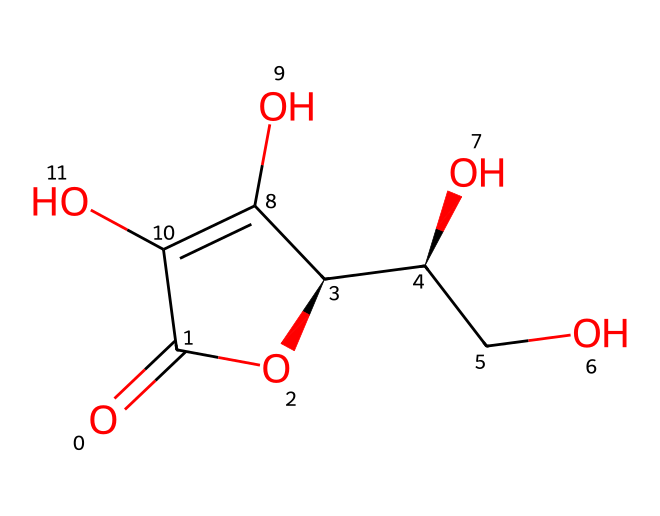What is the common name for this compound? The chemical structure corresponds to ascorbic acid, which is commonly known as Vitamin C. This name is widely recognized in the context of nutrition and biochemistry.
Answer: Vitamin C How many oxygen atoms are present in the molecule? By examining the structure, there are a total of 4 oxygen atoms present. The structure shows several –OH groups and a carbonyl group (C=O), contributing to the total count.
Answer: 4 What functional groups are present in ascorbic acid? The structure reveals multiple hydroxyl groups (–OH) and one carbonyl group (C=O), which are characteristic of alcohols and aldehydes, respectively. These functional groups dictate the molecule's reactivity and solubility properties.
Answer: hydroxyl and carbonyl What is the molecular formula of ascorbic acid? Analyzing the structure reveals the number of carbon (C), hydrogen (H), and oxygen (O) atoms. Upon counting, there are 6 carbons, 8 hydrogens, and 6 oxygens, leading to the molecular formula C6H8O6.
Answer: C6H8O6 Is this molecule polar or nonpolar? The presence of multiple hydroxyl groups lends significant polarity to the structure due to the electronegativity of oxygen atoms. Additionally, hydrogen bonding capabilities enhance its polar characteristics.
Answer: polar What is the primary role of ascorbic acid in human health? Ascorbic acid's primary function is as an antioxidant, helping to neutralize free radicals in the body and prevent oxidative damage, which is crucial for maintaining overall health.
Answer: antioxidant 